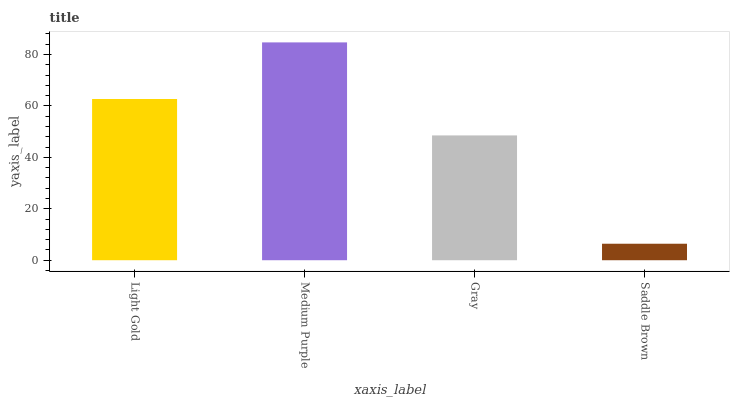Is Gray the minimum?
Answer yes or no. No. Is Gray the maximum?
Answer yes or no. No. Is Medium Purple greater than Gray?
Answer yes or no. Yes. Is Gray less than Medium Purple?
Answer yes or no. Yes. Is Gray greater than Medium Purple?
Answer yes or no. No. Is Medium Purple less than Gray?
Answer yes or no. No. Is Light Gold the high median?
Answer yes or no. Yes. Is Gray the low median?
Answer yes or no. Yes. Is Gray the high median?
Answer yes or no. No. Is Medium Purple the low median?
Answer yes or no. No. 